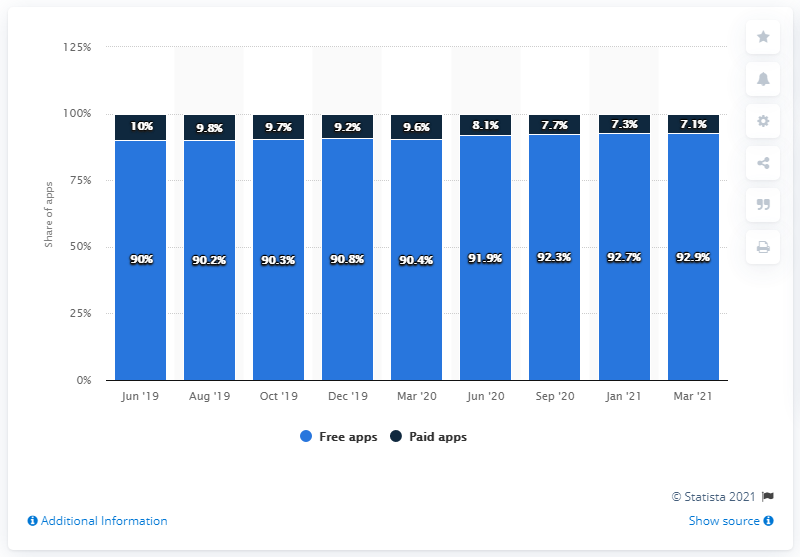Specify some key components in this picture. In March 2021, 92.9% of all iOS applications were available for free. 